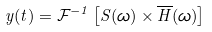Convert formula to latex. <formula><loc_0><loc_0><loc_500><loc_500>y ( t ) = \mathcal { F } ^ { - 1 } \left [ S ( \omega ) \times \overline { H } ( \omega ) \right ]</formula> 